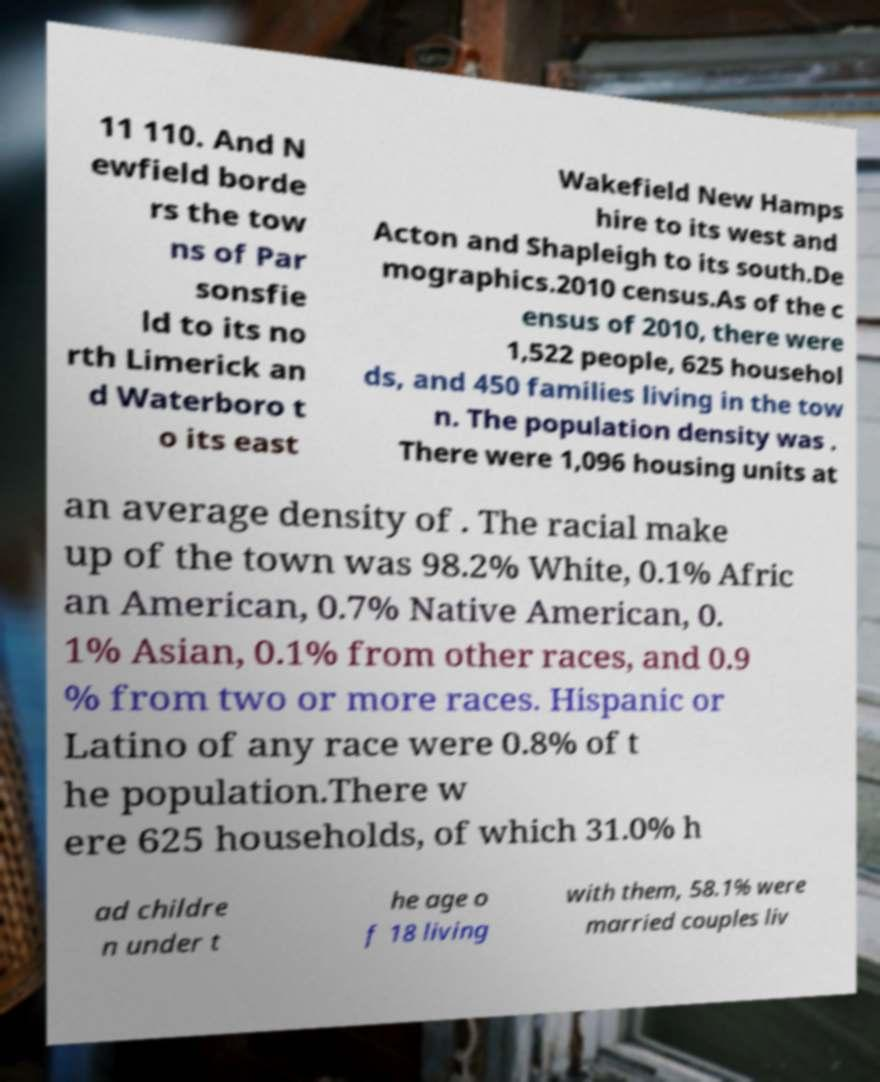Please identify and transcribe the text found in this image. 11 110. And N ewfield borde rs the tow ns of Par sonsfie ld to its no rth Limerick an d Waterboro t o its east Wakefield New Hamps hire to its west and Acton and Shapleigh to its south.De mographics.2010 census.As of the c ensus of 2010, there were 1,522 people, 625 househol ds, and 450 families living in the tow n. The population density was . There were 1,096 housing units at an average density of . The racial make up of the town was 98.2% White, 0.1% Afric an American, 0.7% Native American, 0. 1% Asian, 0.1% from other races, and 0.9 % from two or more races. Hispanic or Latino of any race were 0.8% of t he population.There w ere 625 households, of which 31.0% h ad childre n under t he age o f 18 living with them, 58.1% were married couples liv 